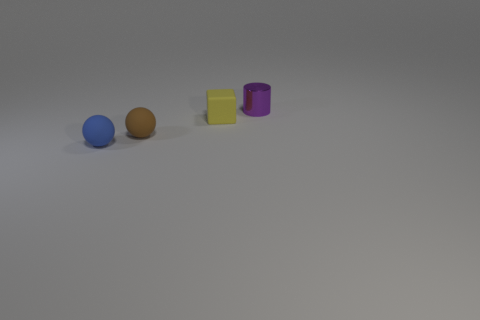Add 2 small green metal spheres. How many objects exist? 6 Subtract all cylinders. How many objects are left? 3 Add 3 blue matte spheres. How many blue matte spheres exist? 4 Subtract 0 gray balls. How many objects are left? 4 Subtract all large cyan matte things. Subtract all cubes. How many objects are left? 3 Add 4 tiny purple metallic things. How many tiny purple metallic things are left? 5 